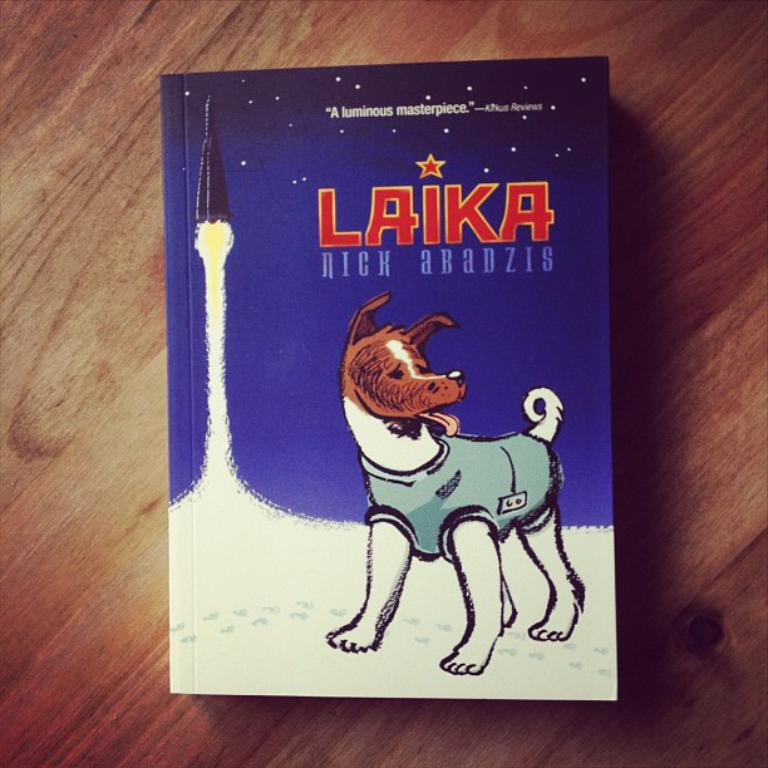What object is in the image? There is a book in the image. Where is the book located? The book is placed on a table. How is the book positioned in the image? The book is in the center of the image. What type of cave can be seen in the background of the image? There is no cave present in the image; it only features a book placed on a table. 